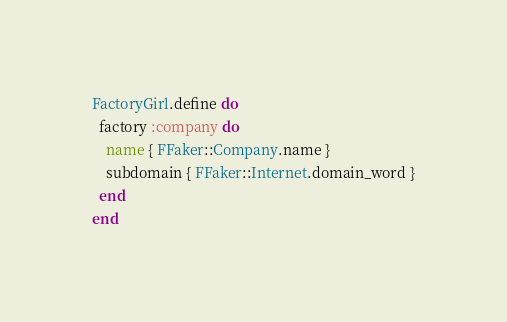<code> <loc_0><loc_0><loc_500><loc_500><_Ruby_>FactoryGirl.define do
  factory :company do
    name { FFaker::Company.name }
    subdomain { FFaker::Internet.domain_word }
  end
end
</code> 